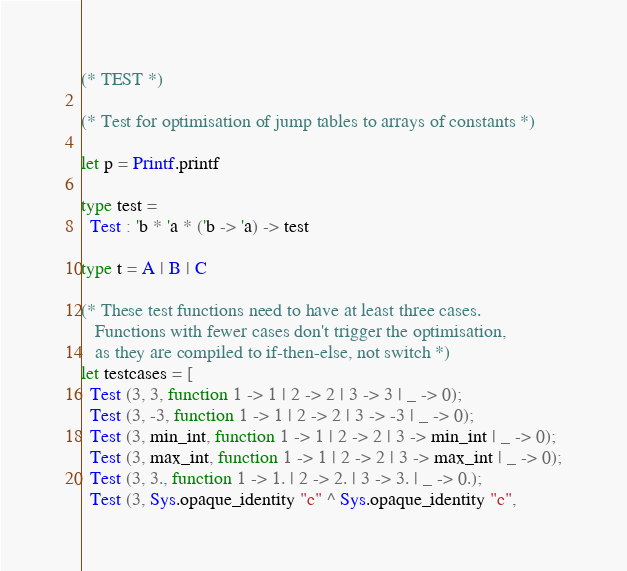<code> <loc_0><loc_0><loc_500><loc_500><_OCaml_>(* TEST *)

(* Test for optimisation of jump tables to arrays of constants *)

let p = Printf.printf

type test =
  Test : 'b * 'a * ('b -> 'a) -> test

type t = A | B | C

(* These test functions need to have at least three cases.
   Functions with fewer cases don't trigger the optimisation,
   as they are compiled to if-then-else, not switch *)
let testcases = [
  Test (3, 3, function 1 -> 1 | 2 -> 2 | 3 -> 3 | _ -> 0);
  Test (3, -3, function 1 -> 1 | 2 -> 2 | 3 -> -3 | _ -> 0);
  Test (3, min_int, function 1 -> 1 | 2 -> 2 | 3 -> min_int | _ -> 0);
  Test (3, max_int, function 1 -> 1 | 2 -> 2 | 3 -> max_int | _ -> 0);
  Test (3, 3., function 1 -> 1. | 2 -> 2. | 3 -> 3. | _ -> 0.);
  Test (3, Sys.opaque_identity "c" ^ Sys.opaque_identity "c",</code> 